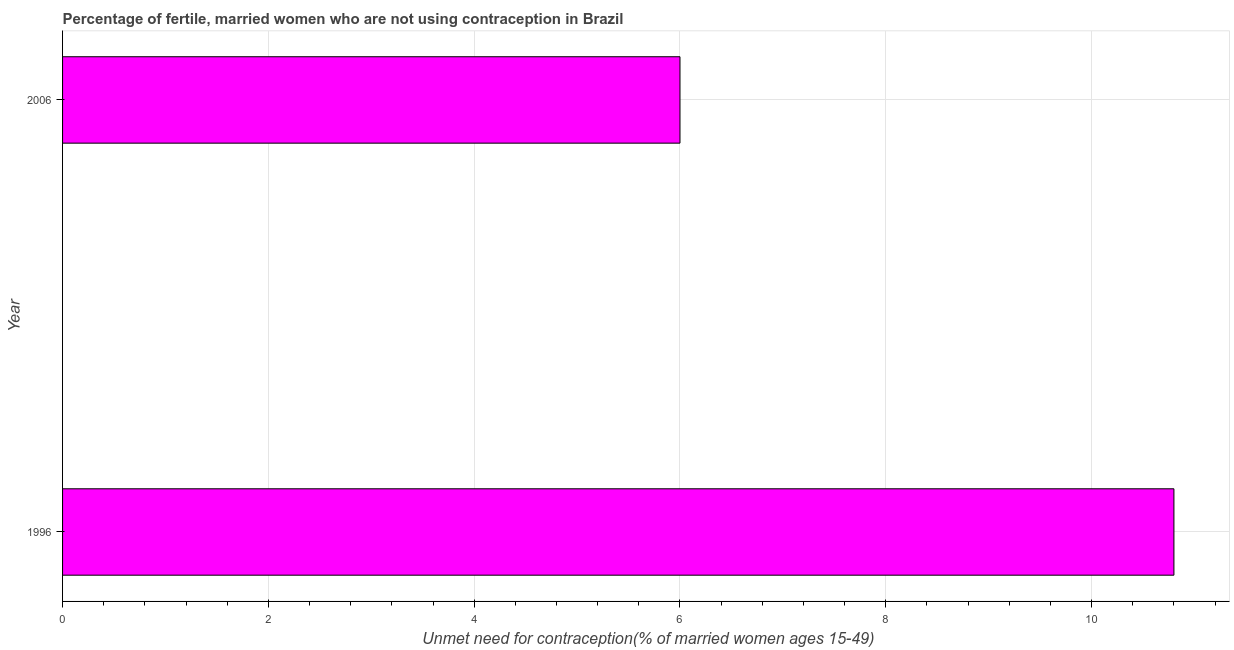Does the graph contain any zero values?
Make the answer very short. No. What is the title of the graph?
Keep it short and to the point. Percentage of fertile, married women who are not using contraception in Brazil. What is the label or title of the X-axis?
Your response must be concise.  Unmet need for contraception(% of married women ages 15-49). What is the label or title of the Y-axis?
Offer a very short reply. Year. Across all years, what is the minimum number of married women who are not using contraception?
Provide a short and direct response. 6. In which year was the number of married women who are not using contraception maximum?
Your response must be concise. 1996. What is the sum of the number of married women who are not using contraception?
Make the answer very short. 16.8. What is the average number of married women who are not using contraception per year?
Provide a short and direct response. 8.4. In how many years, is the number of married women who are not using contraception greater than 4 %?
Keep it short and to the point. 2. In how many years, is the number of married women who are not using contraception greater than the average number of married women who are not using contraception taken over all years?
Keep it short and to the point. 1. What is the  Unmet need for contraception(% of married women ages 15-49) of 2006?
Provide a succinct answer. 6. 